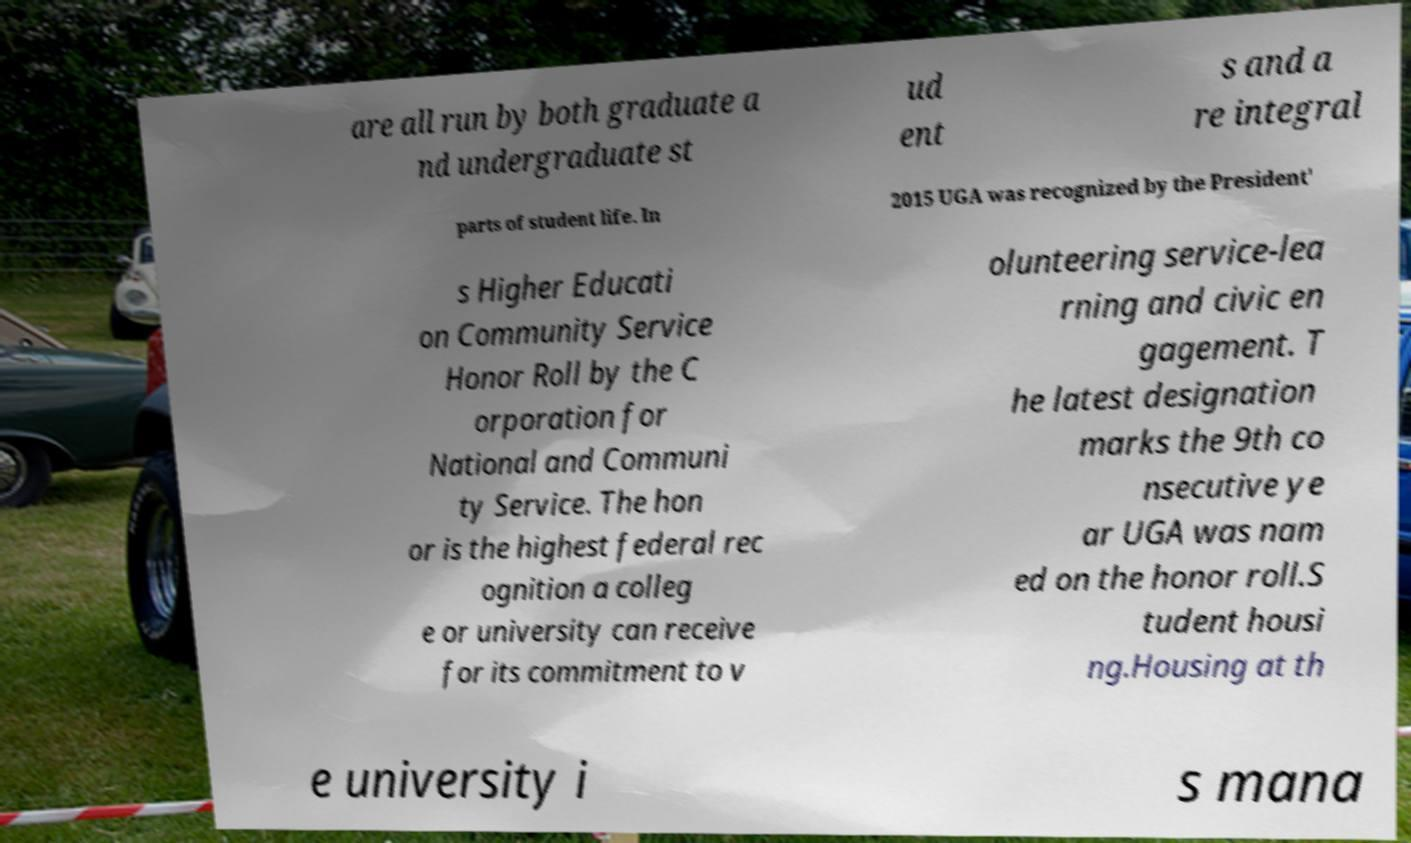I need the written content from this picture converted into text. Can you do that? are all run by both graduate a nd undergraduate st ud ent s and a re integral parts of student life. In 2015 UGA was recognized by the President' s Higher Educati on Community Service Honor Roll by the C orporation for National and Communi ty Service. The hon or is the highest federal rec ognition a colleg e or university can receive for its commitment to v olunteering service-lea rning and civic en gagement. T he latest designation marks the 9th co nsecutive ye ar UGA was nam ed on the honor roll.S tudent housi ng.Housing at th e university i s mana 